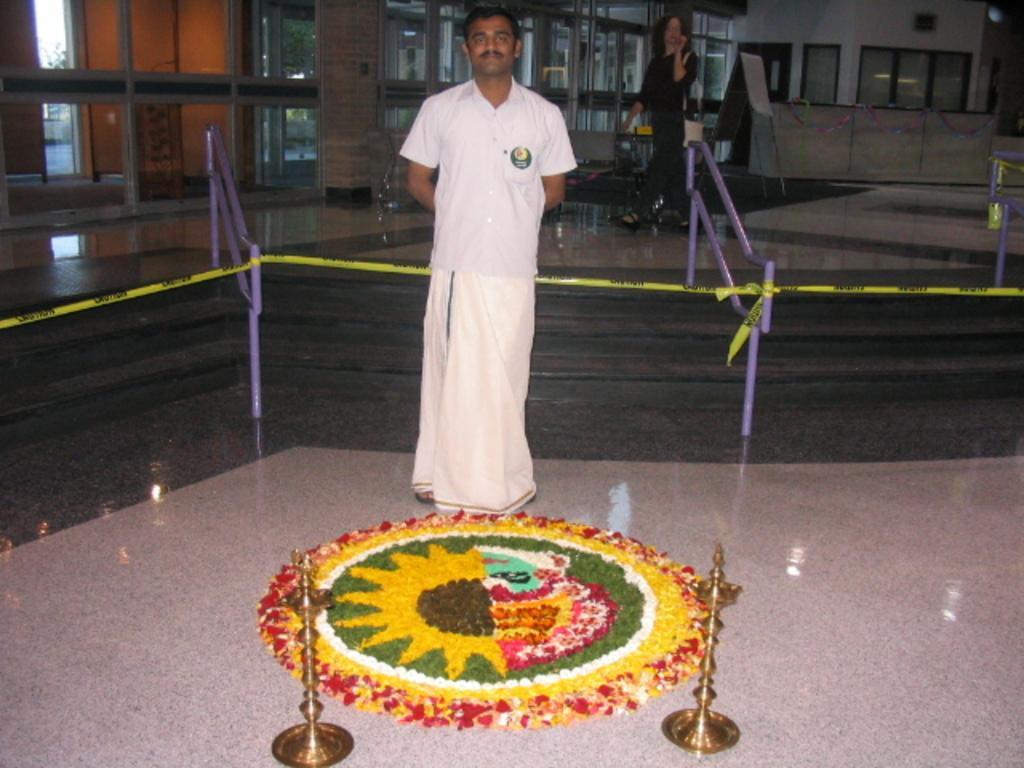In one or two sentences, can you explain what this image depicts? In this picture we can observe a man standing wearing white color shirt and a dhoti. He is smiling. In front of him there is a rangoli on the floor. We can observe yellow color ribbon. In the background there is another person standing. We can observe glass doors here. 